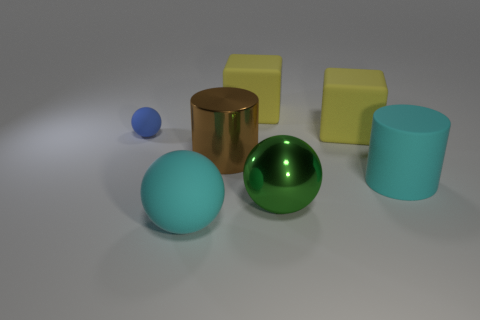Add 1 small red rubber things. How many objects exist? 8 Subtract all tiny rubber balls. How many balls are left? 2 Subtract all cyan cylinders. How many cylinders are left? 1 Subtract all balls. How many objects are left? 4 Subtract all red spheres. How many brown blocks are left? 0 Subtract all small metal cylinders. Subtract all large cubes. How many objects are left? 5 Add 4 blue rubber spheres. How many blue rubber spheres are left? 5 Add 4 cubes. How many cubes exist? 6 Subtract 1 brown cylinders. How many objects are left? 6 Subtract 1 blocks. How many blocks are left? 1 